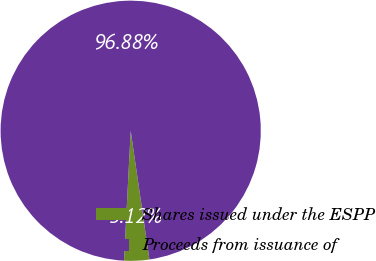<chart> <loc_0><loc_0><loc_500><loc_500><pie_chart><fcel>Shares issued under the ESPP<fcel>Proceeds from issuance of<nl><fcel>3.12%<fcel>96.88%<nl></chart> 